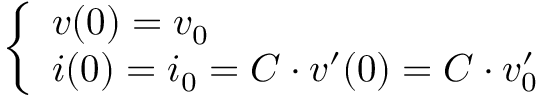<formula> <loc_0><loc_0><loc_500><loc_500>\left \{ \begin{array} { l l } { v ( 0 ) = v _ { 0 } } \\ { i ( 0 ) = i _ { 0 } = C \cdot v ^ { \prime } ( 0 ) = C \cdot v _ { 0 } ^ { \prime } } \end{array}</formula> 